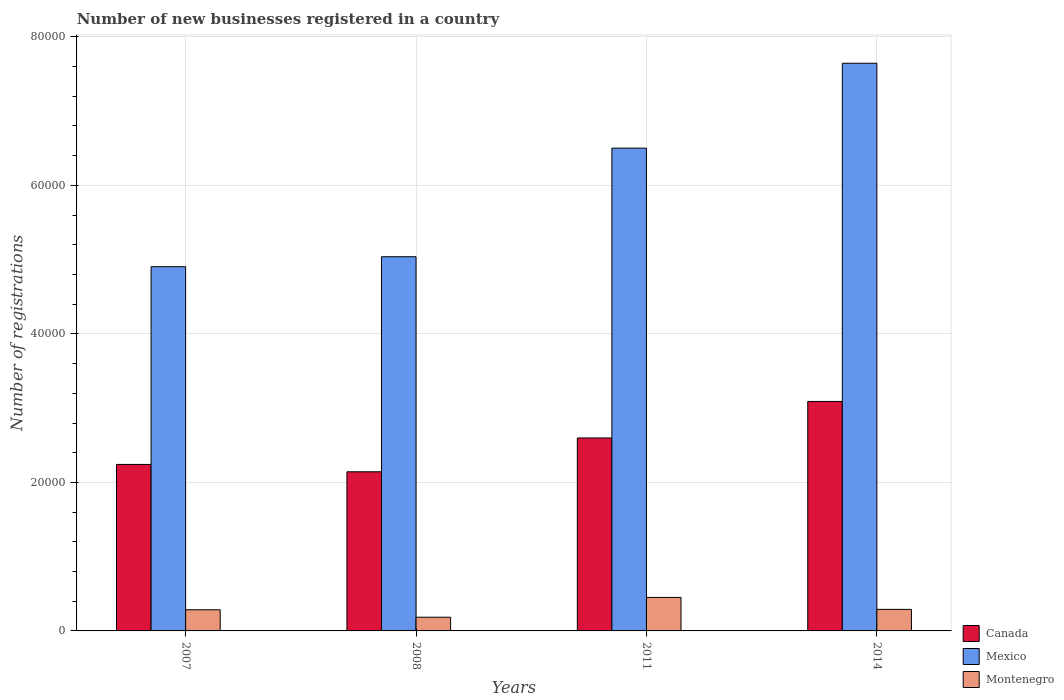Are the number of bars on each tick of the X-axis equal?
Keep it short and to the point. Yes. How many bars are there on the 4th tick from the left?
Your answer should be compact. 3. What is the label of the 1st group of bars from the left?
Give a very brief answer. 2007. What is the number of new businesses registered in Canada in 2008?
Offer a very short reply. 2.14e+04. Across all years, what is the maximum number of new businesses registered in Mexico?
Make the answer very short. 7.64e+04. Across all years, what is the minimum number of new businesses registered in Montenegro?
Ensure brevity in your answer.  1846. In which year was the number of new businesses registered in Mexico minimum?
Make the answer very short. 2007. What is the total number of new businesses registered in Montenegro in the graph?
Offer a terse response. 1.21e+04. What is the difference between the number of new businesses registered in Montenegro in 2007 and that in 2008?
Offer a very short reply. 1002. What is the difference between the number of new businesses registered in Montenegro in 2007 and the number of new businesses registered in Mexico in 2014?
Keep it short and to the point. -7.36e+04. What is the average number of new businesses registered in Mexico per year?
Give a very brief answer. 6.02e+04. In the year 2007, what is the difference between the number of new businesses registered in Canada and number of new businesses registered in Montenegro?
Give a very brief answer. 1.96e+04. What is the ratio of the number of new businesses registered in Montenegro in 2007 to that in 2011?
Make the answer very short. 0.63. What is the difference between the highest and the second highest number of new businesses registered in Canada?
Provide a succinct answer. 4919. What is the difference between the highest and the lowest number of new businesses registered in Mexico?
Provide a succinct answer. 2.74e+04. Is the sum of the number of new businesses registered in Canada in 2008 and 2011 greater than the maximum number of new businesses registered in Montenegro across all years?
Your answer should be compact. Yes. What does the 3rd bar from the left in 2007 represents?
Give a very brief answer. Montenegro. Is it the case that in every year, the sum of the number of new businesses registered in Mexico and number of new businesses registered in Montenegro is greater than the number of new businesses registered in Canada?
Offer a very short reply. Yes. What is the difference between two consecutive major ticks on the Y-axis?
Ensure brevity in your answer.  2.00e+04. Does the graph contain any zero values?
Offer a terse response. No. Does the graph contain grids?
Give a very brief answer. Yes. How many legend labels are there?
Keep it short and to the point. 3. How are the legend labels stacked?
Your answer should be very brief. Vertical. What is the title of the graph?
Provide a succinct answer. Number of new businesses registered in a country. Does "United Kingdom" appear as one of the legend labels in the graph?
Ensure brevity in your answer.  No. What is the label or title of the Y-axis?
Your response must be concise. Number of registrations. What is the Number of registrations in Canada in 2007?
Make the answer very short. 2.24e+04. What is the Number of registrations in Mexico in 2007?
Keep it short and to the point. 4.90e+04. What is the Number of registrations in Montenegro in 2007?
Provide a short and direct response. 2848. What is the Number of registrations in Canada in 2008?
Make the answer very short. 2.14e+04. What is the Number of registrations of Mexico in 2008?
Ensure brevity in your answer.  5.04e+04. What is the Number of registrations in Montenegro in 2008?
Your answer should be compact. 1846. What is the Number of registrations of Canada in 2011?
Your answer should be very brief. 2.60e+04. What is the Number of registrations in Mexico in 2011?
Your answer should be very brief. 6.50e+04. What is the Number of registrations of Montenegro in 2011?
Your answer should be very brief. 4513. What is the Number of registrations in Canada in 2014?
Offer a terse response. 3.09e+04. What is the Number of registrations of Mexico in 2014?
Make the answer very short. 7.64e+04. What is the Number of registrations in Montenegro in 2014?
Ensure brevity in your answer.  2901. Across all years, what is the maximum Number of registrations of Canada?
Your answer should be compact. 3.09e+04. Across all years, what is the maximum Number of registrations of Mexico?
Keep it short and to the point. 7.64e+04. Across all years, what is the maximum Number of registrations in Montenegro?
Keep it short and to the point. 4513. Across all years, what is the minimum Number of registrations in Canada?
Provide a short and direct response. 2.14e+04. Across all years, what is the minimum Number of registrations in Mexico?
Ensure brevity in your answer.  4.90e+04. Across all years, what is the minimum Number of registrations in Montenegro?
Keep it short and to the point. 1846. What is the total Number of registrations of Canada in the graph?
Provide a succinct answer. 1.01e+05. What is the total Number of registrations in Mexico in the graph?
Provide a succinct answer. 2.41e+05. What is the total Number of registrations in Montenegro in the graph?
Keep it short and to the point. 1.21e+04. What is the difference between the Number of registrations in Canada in 2007 and that in 2008?
Provide a short and direct response. 990. What is the difference between the Number of registrations in Mexico in 2007 and that in 2008?
Keep it short and to the point. -1342. What is the difference between the Number of registrations of Montenegro in 2007 and that in 2008?
Offer a very short reply. 1002. What is the difference between the Number of registrations of Canada in 2007 and that in 2011?
Keep it short and to the point. -3564. What is the difference between the Number of registrations in Mexico in 2007 and that in 2011?
Your answer should be compact. -1.60e+04. What is the difference between the Number of registrations in Montenegro in 2007 and that in 2011?
Make the answer very short. -1665. What is the difference between the Number of registrations in Canada in 2007 and that in 2014?
Offer a terse response. -8483. What is the difference between the Number of registrations of Mexico in 2007 and that in 2014?
Ensure brevity in your answer.  -2.74e+04. What is the difference between the Number of registrations of Montenegro in 2007 and that in 2014?
Provide a succinct answer. -53. What is the difference between the Number of registrations of Canada in 2008 and that in 2011?
Provide a short and direct response. -4554. What is the difference between the Number of registrations in Mexico in 2008 and that in 2011?
Your answer should be very brief. -1.46e+04. What is the difference between the Number of registrations of Montenegro in 2008 and that in 2011?
Offer a very short reply. -2667. What is the difference between the Number of registrations in Canada in 2008 and that in 2014?
Your answer should be very brief. -9473. What is the difference between the Number of registrations in Mexico in 2008 and that in 2014?
Offer a very short reply. -2.61e+04. What is the difference between the Number of registrations in Montenegro in 2008 and that in 2014?
Your answer should be very brief. -1055. What is the difference between the Number of registrations in Canada in 2011 and that in 2014?
Keep it short and to the point. -4919. What is the difference between the Number of registrations in Mexico in 2011 and that in 2014?
Provide a short and direct response. -1.14e+04. What is the difference between the Number of registrations of Montenegro in 2011 and that in 2014?
Your response must be concise. 1612. What is the difference between the Number of registrations in Canada in 2007 and the Number of registrations in Mexico in 2008?
Your answer should be very brief. -2.80e+04. What is the difference between the Number of registrations in Canada in 2007 and the Number of registrations in Montenegro in 2008?
Ensure brevity in your answer.  2.06e+04. What is the difference between the Number of registrations in Mexico in 2007 and the Number of registrations in Montenegro in 2008?
Offer a terse response. 4.72e+04. What is the difference between the Number of registrations in Canada in 2007 and the Number of registrations in Mexico in 2011?
Your answer should be very brief. -4.26e+04. What is the difference between the Number of registrations of Canada in 2007 and the Number of registrations of Montenegro in 2011?
Make the answer very short. 1.79e+04. What is the difference between the Number of registrations of Mexico in 2007 and the Number of registrations of Montenegro in 2011?
Offer a very short reply. 4.45e+04. What is the difference between the Number of registrations of Canada in 2007 and the Number of registrations of Mexico in 2014?
Your response must be concise. -5.40e+04. What is the difference between the Number of registrations of Canada in 2007 and the Number of registrations of Montenegro in 2014?
Your answer should be very brief. 1.95e+04. What is the difference between the Number of registrations of Mexico in 2007 and the Number of registrations of Montenegro in 2014?
Offer a very short reply. 4.61e+04. What is the difference between the Number of registrations of Canada in 2008 and the Number of registrations of Mexico in 2011?
Provide a short and direct response. -4.36e+04. What is the difference between the Number of registrations of Canada in 2008 and the Number of registrations of Montenegro in 2011?
Your answer should be very brief. 1.69e+04. What is the difference between the Number of registrations in Mexico in 2008 and the Number of registrations in Montenegro in 2011?
Provide a short and direct response. 4.59e+04. What is the difference between the Number of registrations of Canada in 2008 and the Number of registrations of Mexico in 2014?
Your answer should be very brief. -5.50e+04. What is the difference between the Number of registrations in Canada in 2008 and the Number of registrations in Montenegro in 2014?
Keep it short and to the point. 1.85e+04. What is the difference between the Number of registrations of Mexico in 2008 and the Number of registrations of Montenegro in 2014?
Your answer should be compact. 4.75e+04. What is the difference between the Number of registrations in Canada in 2011 and the Number of registrations in Mexico in 2014?
Your answer should be very brief. -5.05e+04. What is the difference between the Number of registrations of Canada in 2011 and the Number of registrations of Montenegro in 2014?
Make the answer very short. 2.31e+04. What is the difference between the Number of registrations of Mexico in 2011 and the Number of registrations of Montenegro in 2014?
Provide a succinct answer. 6.21e+04. What is the average Number of registrations of Canada per year?
Offer a terse response. 2.52e+04. What is the average Number of registrations of Mexico per year?
Provide a short and direct response. 6.02e+04. What is the average Number of registrations of Montenegro per year?
Your answer should be compact. 3027. In the year 2007, what is the difference between the Number of registrations in Canada and Number of registrations in Mexico?
Your response must be concise. -2.66e+04. In the year 2007, what is the difference between the Number of registrations in Canada and Number of registrations in Montenegro?
Offer a terse response. 1.96e+04. In the year 2007, what is the difference between the Number of registrations in Mexico and Number of registrations in Montenegro?
Give a very brief answer. 4.62e+04. In the year 2008, what is the difference between the Number of registrations in Canada and Number of registrations in Mexico?
Ensure brevity in your answer.  -2.90e+04. In the year 2008, what is the difference between the Number of registrations in Canada and Number of registrations in Montenegro?
Offer a terse response. 1.96e+04. In the year 2008, what is the difference between the Number of registrations in Mexico and Number of registrations in Montenegro?
Ensure brevity in your answer.  4.85e+04. In the year 2011, what is the difference between the Number of registrations in Canada and Number of registrations in Mexico?
Provide a short and direct response. -3.90e+04. In the year 2011, what is the difference between the Number of registrations in Canada and Number of registrations in Montenegro?
Give a very brief answer. 2.15e+04. In the year 2011, what is the difference between the Number of registrations of Mexico and Number of registrations of Montenegro?
Ensure brevity in your answer.  6.05e+04. In the year 2014, what is the difference between the Number of registrations of Canada and Number of registrations of Mexico?
Your answer should be compact. -4.55e+04. In the year 2014, what is the difference between the Number of registrations of Canada and Number of registrations of Montenegro?
Ensure brevity in your answer.  2.80e+04. In the year 2014, what is the difference between the Number of registrations of Mexico and Number of registrations of Montenegro?
Your answer should be compact. 7.35e+04. What is the ratio of the Number of registrations of Canada in 2007 to that in 2008?
Your response must be concise. 1.05. What is the ratio of the Number of registrations in Mexico in 2007 to that in 2008?
Offer a very short reply. 0.97. What is the ratio of the Number of registrations in Montenegro in 2007 to that in 2008?
Offer a very short reply. 1.54. What is the ratio of the Number of registrations in Canada in 2007 to that in 2011?
Make the answer very short. 0.86. What is the ratio of the Number of registrations in Mexico in 2007 to that in 2011?
Your answer should be very brief. 0.75. What is the ratio of the Number of registrations of Montenegro in 2007 to that in 2011?
Provide a succinct answer. 0.63. What is the ratio of the Number of registrations in Canada in 2007 to that in 2014?
Your response must be concise. 0.73. What is the ratio of the Number of registrations of Mexico in 2007 to that in 2014?
Your answer should be compact. 0.64. What is the ratio of the Number of registrations of Montenegro in 2007 to that in 2014?
Your response must be concise. 0.98. What is the ratio of the Number of registrations in Canada in 2008 to that in 2011?
Your answer should be compact. 0.82. What is the ratio of the Number of registrations in Mexico in 2008 to that in 2011?
Provide a short and direct response. 0.78. What is the ratio of the Number of registrations of Montenegro in 2008 to that in 2011?
Provide a short and direct response. 0.41. What is the ratio of the Number of registrations in Canada in 2008 to that in 2014?
Make the answer very short. 0.69. What is the ratio of the Number of registrations of Mexico in 2008 to that in 2014?
Give a very brief answer. 0.66. What is the ratio of the Number of registrations in Montenegro in 2008 to that in 2014?
Keep it short and to the point. 0.64. What is the ratio of the Number of registrations of Canada in 2011 to that in 2014?
Keep it short and to the point. 0.84. What is the ratio of the Number of registrations of Mexico in 2011 to that in 2014?
Provide a succinct answer. 0.85. What is the ratio of the Number of registrations of Montenegro in 2011 to that in 2014?
Provide a short and direct response. 1.56. What is the difference between the highest and the second highest Number of registrations of Canada?
Your response must be concise. 4919. What is the difference between the highest and the second highest Number of registrations in Mexico?
Give a very brief answer. 1.14e+04. What is the difference between the highest and the second highest Number of registrations of Montenegro?
Offer a very short reply. 1612. What is the difference between the highest and the lowest Number of registrations in Canada?
Offer a terse response. 9473. What is the difference between the highest and the lowest Number of registrations in Mexico?
Give a very brief answer. 2.74e+04. What is the difference between the highest and the lowest Number of registrations in Montenegro?
Give a very brief answer. 2667. 